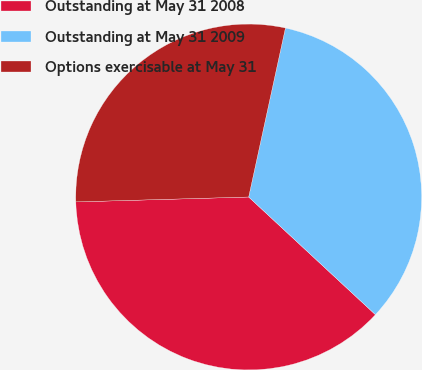Convert chart to OTSL. <chart><loc_0><loc_0><loc_500><loc_500><pie_chart><fcel>Outstanding at May 31 2008<fcel>Outstanding at May 31 2009<fcel>Options exercisable at May 31<nl><fcel>37.64%<fcel>33.5%<fcel>28.86%<nl></chart> 